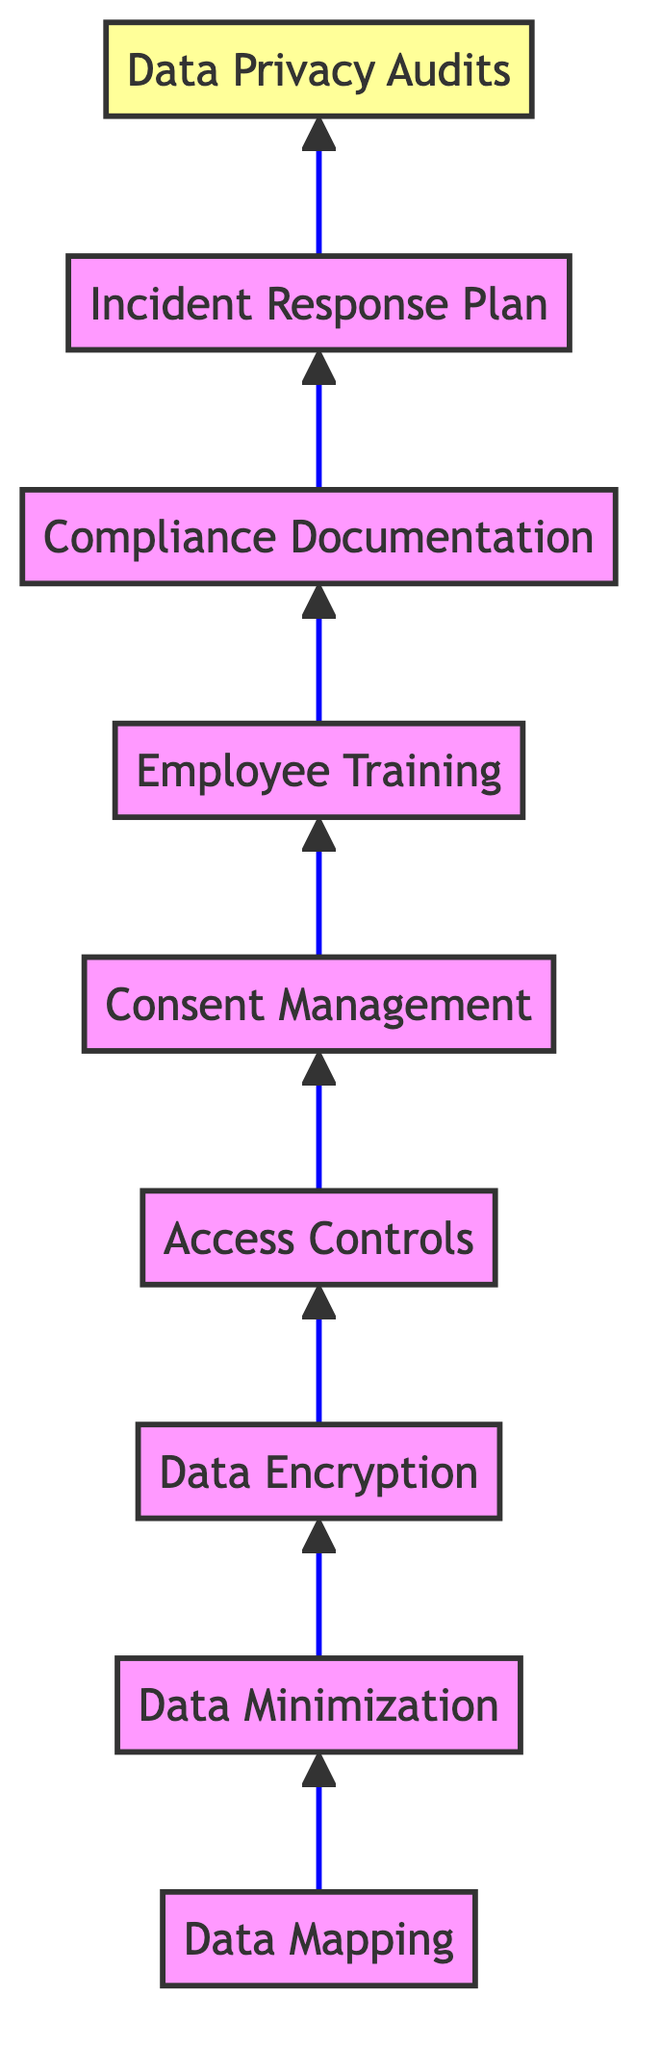What is the top step in the compliance process? The top step in the compliance process, as indicated in the diagram, is "Data Privacy Audits", which is the final node at the top of the flow.
Answer: Data Privacy Audits How many total steps are there in this compliance process? The diagram features a total of 8 steps, each represented by a node starting from "Data Mapping" at the bottom up to "Data Privacy Audits" at the top.
Answer: 8 What step comes immediately before the "Incident Response Plan"? The step immediately before the "Incident Response Plan" in the flow is "Compliance Documentation", which points upward towards the response plan node.
Answer: Compliance Documentation Which step focuses on limiting data access to authorized personnel? The step that focuses on limiting data access is "Access Controls", which is strategically placed before "Consent Management" in the flow.
Answer: Access Controls How does "Data Mapping" relate to "Data Minimization"? "Data Mapping" directly leads into "Data Minimization", as indicated by the arrow connecting these two nodes in the diagram, showing the flow from mapping data to reducing its amount collected.
Answer: Data Mapping leads to Data Minimization Which step involves training for employees on data privacy practices? The "Employee Training" step involves training sessions for staff on data privacy best practices, highlighted in the flow as a step leading to "Compliance Documentation".
Answer: Employee Training What is the last step that follows "Consent Management"? "Employee Training" is the last step that follows "Consent Management" in the sequence of the diagram, indicating the importance of training after obtaining consent.
Answer: Employee Training What is the primary purpose of the "Data Encryption" step? The primary purpose of the "Data Encryption" step is to apply security measures for protecting data, specifically indicating methods for safeguarding data both at rest and in transit.
Answer: Protecting data Which step focuses on regular assessments of data privacy measures? The step focused on regular assessments of data privacy measures is "Data Privacy Audits", which is positioned at the top of the flow chart, emphasizing its significance in the compliance process.
Answer: Data Privacy Audits 